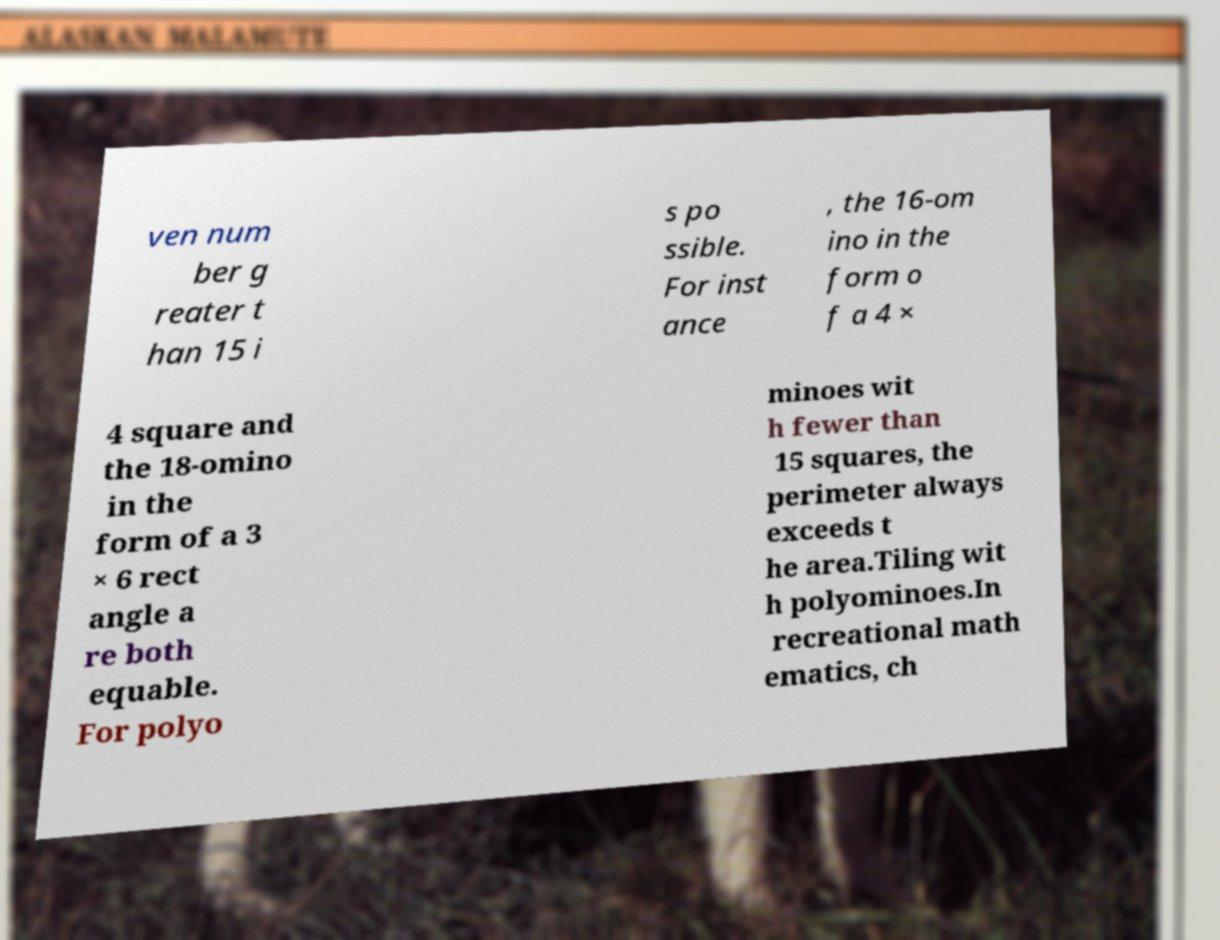I need the written content from this picture converted into text. Can you do that? ven num ber g reater t han 15 i s po ssible. For inst ance , the 16-om ino in the form o f a 4 × 4 square and the 18-omino in the form of a 3 × 6 rect angle a re both equable. For polyo minoes wit h fewer than 15 squares, the perimeter always exceeds t he area.Tiling wit h polyominoes.In recreational math ematics, ch 